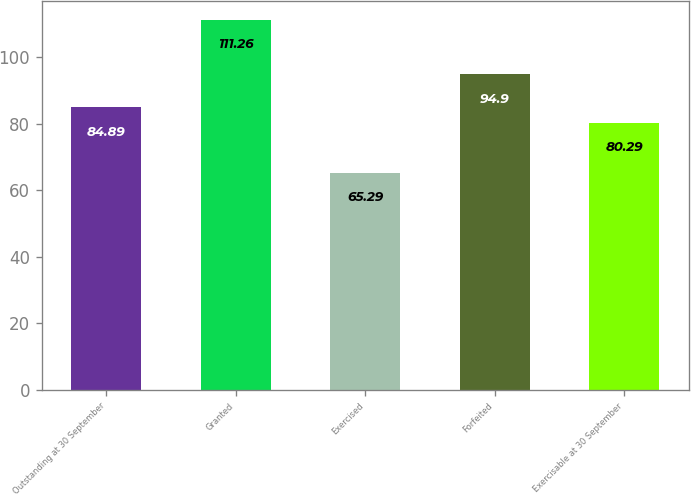Convert chart to OTSL. <chart><loc_0><loc_0><loc_500><loc_500><bar_chart><fcel>Outstanding at 30 September<fcel>Granted<fcel>Exercised<fcel>Forfeited<fcel>Exercisable at 30 September<nl><fcel>84.89<fcel>111.26<fcel>65.29<fcel>94.9<fcel>80.29<nl></chart> 